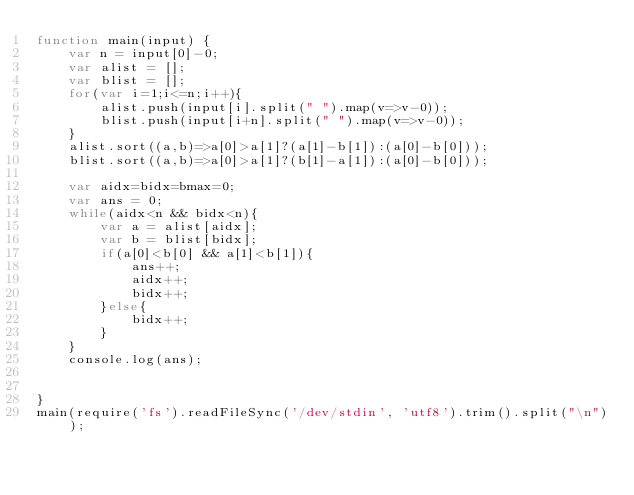Convert code to text. <code><loc_0><loc_0><loc_500><loc_500><_JavaScript_>function main(input) {
    var n = input[0]-0;
    var alist = [];
    var blist = [];
    for(var i=1;i<=n;i++){
        alist.push(input[i].split(" ").map(v=>v-0));
        blist.push(input[i+n].split(" ").map(v=>v-0));
    }
    alist.sort((a,b)=>a[0]>a[1]?(a[1]-b[1]):(a[0]-b[0]));
    blist.sort((a,b)=>a[0]>a[1]?(b[1]-a[1]):(a[0]-b[0]));
    
    var aidx=bidx=bmax=0;
    var ans = 0;
    while(aidx<n && bidx<n){
        var a = alist[aidx];
        var b = blist[bidx];
        if(a[0]<b[0] && a[1]<b[1]){
            ans++;
            aidx++;
            bidx++;
        }else{
            bidx++;
        }
    }
    console.log(ans);
    

}
main(require('fs').readFileSync('/dev/stdin', 'utf8').trim().split("\n"));</code> 